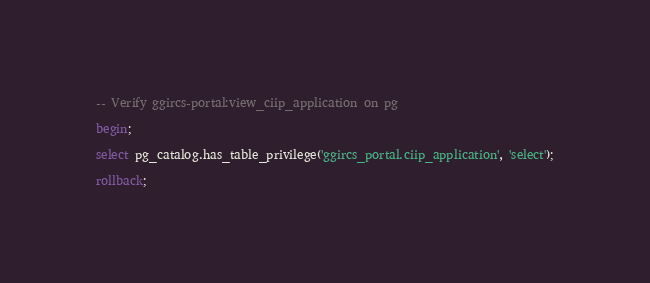Convert code to text. <code><loc_0><loc_0><loc_500><loc_500><_SQL_>-- Verify ggircs-portal:view_ciip_application on pg

begin;

select pg_catalog.has_table_privilege('ggircs_portal.ciip_application', 'select');

rollback;
</code> 